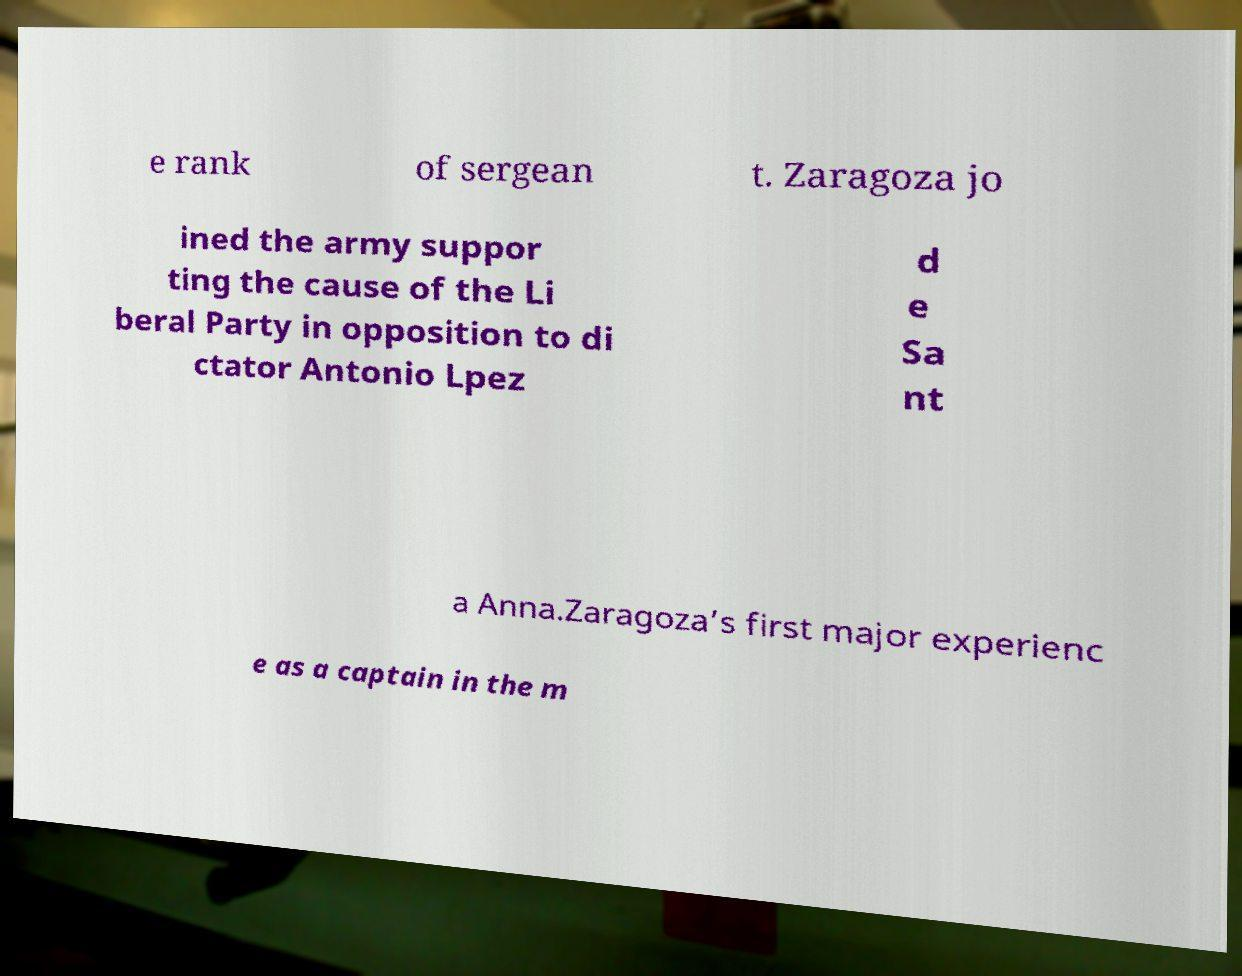What messages or text are displayed in this image? I need them in a readable, typed format. e rank of sergean t. Zaragoza jo ined the army suppor ting the cause of the Li beral Party in opposition to di ctator Antonio Lpez d e Sa nt a Anna.Zaragoza’s first major experienc e as a captain in the m 